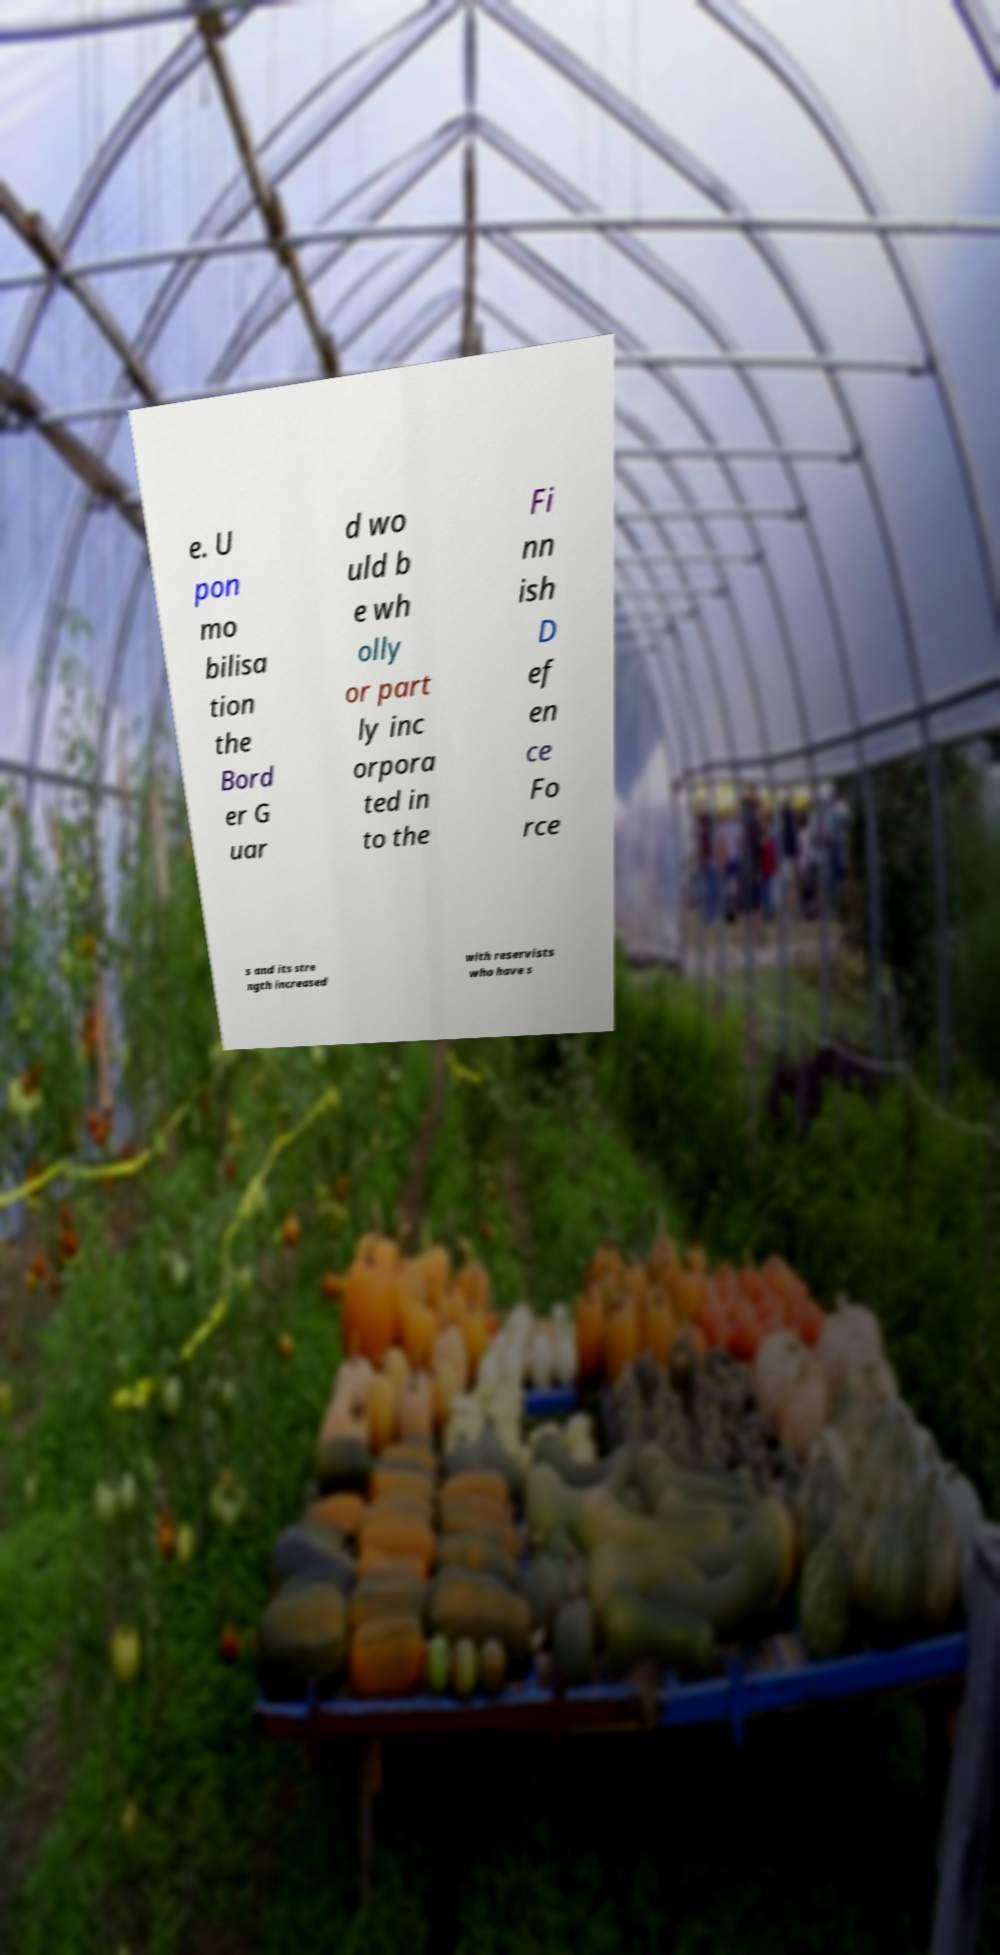For documentation purposes, I need the text within this image transcribed. Could you provide that? e. U pon mo bilisa tion the Bord er G uar d wo uld b e wh olly or part ly inc orpora ted in to the Fi nn ish D ef en ce Fo rce s and its stre ngth increased with reservists who have s 